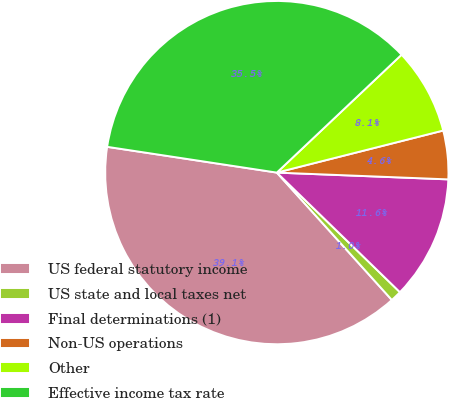<chart> <loc_0><loc_0><loc_500><loc_500><pie_chart><fcel>US federal statutory income<fcel>US state and local taxes net<fcel>Final determinations (1)<fcel>Non-US operations<fcel>Other<fcel>Effective income tax rate<nl><fcel>39.09%<fcel>1.04%<fcel>11.64%<fcel>4.57%<fcel>8.11%<fcel>35.55%<nl></chart> 